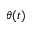Convert formula to latex. <formula><loc_0><loc_0><loc_500><loc_500>\theta ( t )</formula> 